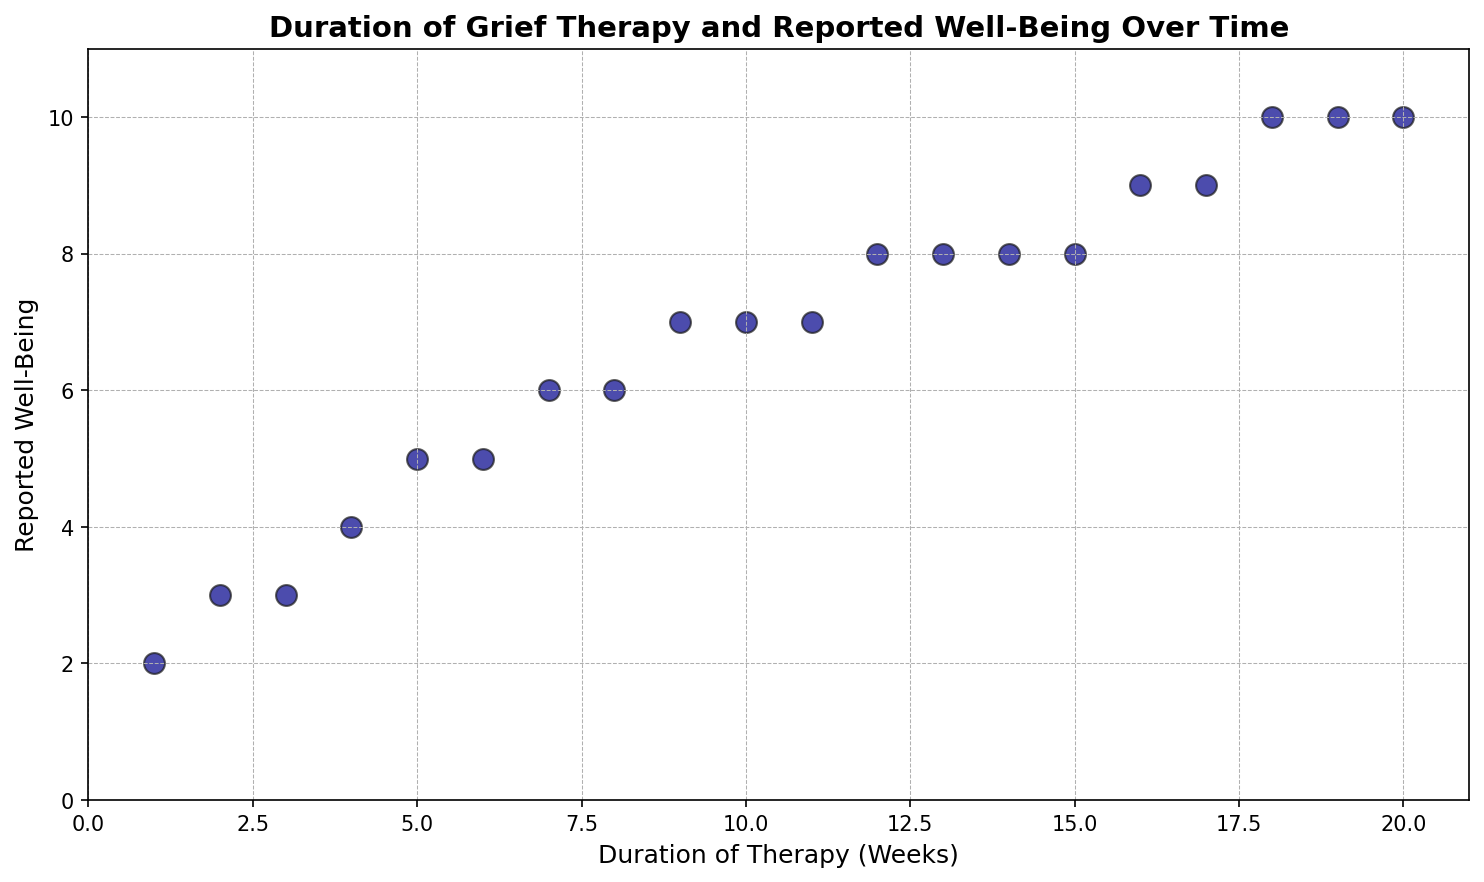What is the value of reported well-being after 10 weeks of therapy? To find this, locate the point on the scatter plot where the x-axis (Duration of Therapy in Weeks) is 10. The corresponding y-axis (Reported Well-Being) value will be the answer.
Answer: 7 How much did the reported well-being increase from week 1 to week 20? At week 1, the reported well-being is 2. At week 20, it is 10. The increase can be calculated by subtracting the well-being at week 1 from the well-being at week 20: 10 - 2 = 8.
Answer: 8 What is the average reported well-being between weeks 15 and 20? Identify the reported well-being at weeks 15, 16, 17, 18, 19, and 20: 8, 9, 9, 10, 10, 10. Then calculate the average: (8 + 9 + 9 + 10 + 10 + 10) / 6 = 56 / 6 = ~9.33.
Answer: ~9.33 At which weeks does the reported well-being first reach 8? Look at the scatter plot and find the x-axis values where the y-axis value is 8. The first instance occurs at week 12.
Answer: 12 Between which two consecutive weeks is the increase in reported well-being the largest? Check the reported well-being values between consecutive weeks. The largest increase is between weeks 17 and 18 where the well-being jumps from 9 to 10.
Answer: Between weeks 17 and 18 How many weeks did it take for the reported well-being to go from 2 to 7? Identify the weeks at which the reported well-being is 2 and 7. It starts at 2 at week 1 and reaches 7 at week 9. From week 1 to week 9, it takes 8 weeks.
Answer: 8 weeks Does the reported well-being plateau at any point? Examine the scatter plot for horizontal segments where reported well-being does not change despite an increase in duration. It plateaus noticeably at well-being level 8 from week 15 to week 16.
Answer: Yes How many weeks have a reported well-being of 10? Count the points on the scatter plot where the y-axis value is 10. There are three such weeks: 18, 19, and 20.
Answer: 3 weeks What is the difference in reported well-being between the first and sixth week? At week 1, the reported well-being is 2. At week 6, it is 5. The difference is 5 - 2 = 3.
Answer: 3 What is the trend of reported well-being as therapy duration increases to 20 weeks? Observing the scatter plot, the general trend shows an increasing curve of reported well-being as duration increases, though there are periods of plateauing.
Answer: Increases 